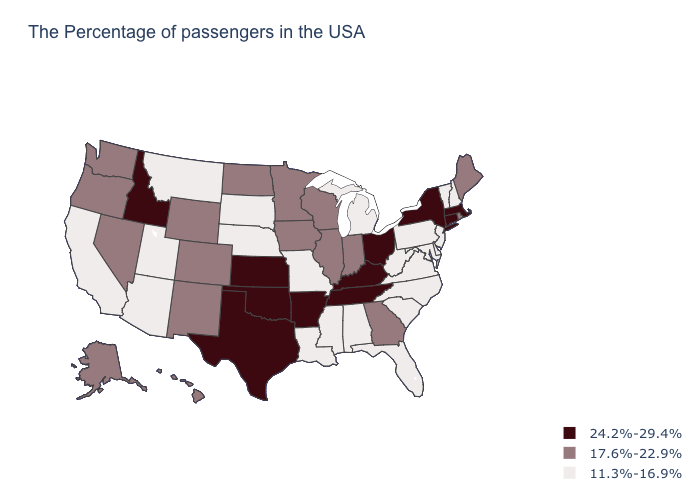Among the states that border Connecticut , does New York have the highest value?
Concise answer only. Yes. Is the legend a continuous bar?
Write a very short answer. No. Among the states that border Massachusetts , does New York have the highest value?
Write a very short answer. Yes. Does Florida have the same value as Wyoming?
Be succinct. No. What is the value of North Carolina?
Answer briefly. 11.3%-16.9%. What is the lowest value in states that border Kansas?
Quick response, please. 11.3%-16.9%. Does the map have missing data?
Concise answer only. No. Name the states that have a value in the range 17.6%-22.9%?
Quick response, please. Maine, Rhode Island, Georgia, Indiana, Wisconsin, Illinois, Minnesota, Iowa, North Dakota, Wyoming, Colorado, New Mexico, Nevada, Washington, Oregon, Alaska, Hawaii. What is the lowest value in the USA?
Short answer required. 11.3%-16.9%. Name the states that have a value in the range 24.2%-29.4%?
Short answer required. Massachusetts, Connecticut, New York, Ohio, Kentucky, Tennessee, Arkansas, Kansas, Oklahoma, Texas, Idaho. Does New Jersey have the lowest value in the USA?
Give a very brief answer. Yes. What is the value of Kentucky?
Quick response, please. 24.2%-29.4%. Name the states that have a value in the range 17.6%-22.9%?
Answer briefly. Maine, Rhode Island, Georgia, Indiana, Wisconsin, Illinois, Minnesota, Iowa, North Dakota, Wyoming, Colorado, New Mexico, Nevada, Washington, Oregon, Alaska, Hawaii. What is the highest value in the USA?
Concise answer only. 24.2%-29.4%. What is the lowest value in the USA?
Be succinct. 11.3%-16.9%. 